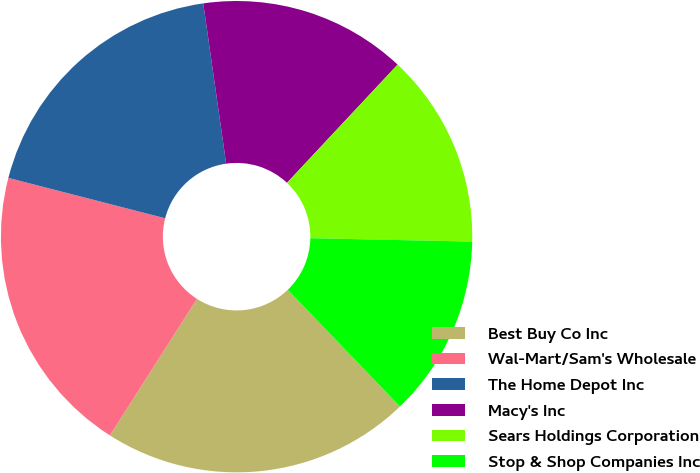Convert chart to OTSL. <chart><loc_0><loc_0><loc_500><loc_500><pie_chart><fcel>Best Buy Co Inc<fcel>Wal-Mart/Sam's Wholesale<fcel>The Home Depot Inc<fcel>Macy's Inc<fcel>Sears Holdings Corporation<fcel>Stop & Shop Companies Inc<nl><fcel>21.22%<fcel>19.98%<fcel>18.73%<fcel>14.23%<fcel>13.36%<fcel>12.48%<nl></chart> 